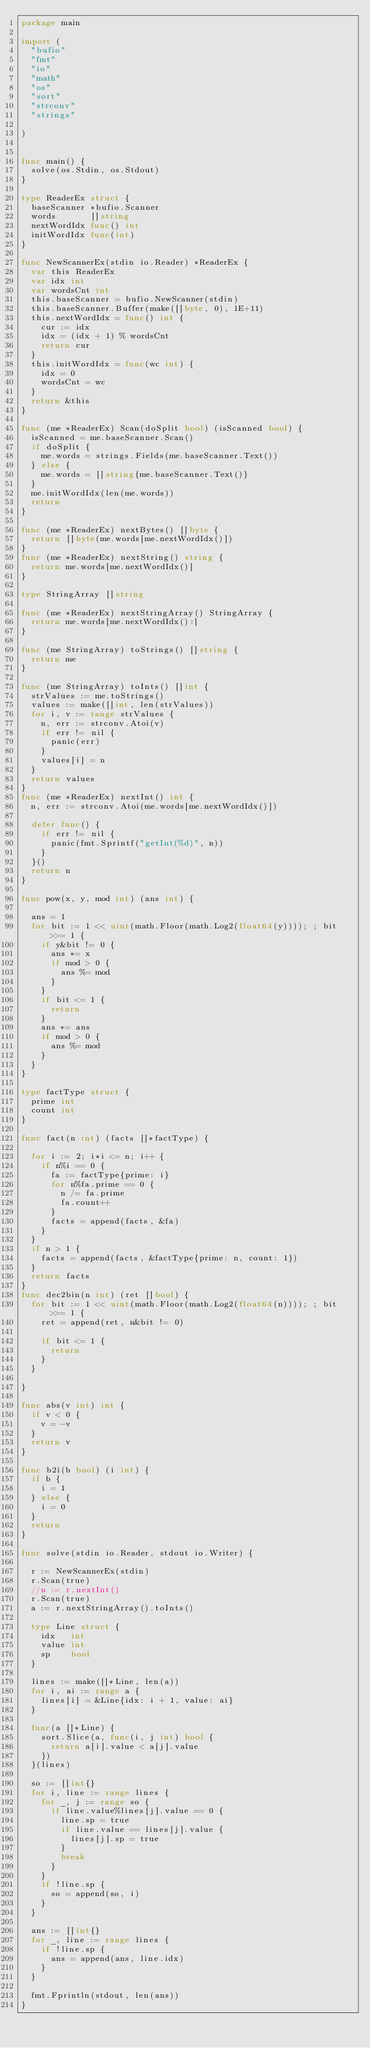<code> <loc_0><loc_0><loc_500><loc_500><_Go_>package main

import (
	"bufio"
	"fmt"
	"io"
	"math"
	"os"
	"sort"
	"strconv"
	"strings"

)


func main() {
	solve(os.Stdin, os.Stdout)
}

type ReaderEx struct {
	baseScanner *bufio.Scanner
	words       []string
	nextWordIdx func() int
	initWordIdx func(int)
}

func NewScannerEx(stdin io.Reader) *ReaderEx {
	var this ReaderEx
	var idx int
	var wordsCnt int
	this.baseScanner = bufio.NewScanner(stdin)
	this.baseScanner.Buffer(make([]byte, 0), 1E+11)
	this.nextWordIdx = func() int {
		cur := idx
		idx = (idx + 1) % wordsCnt
		return cur
	}
	this.initWordIdx = func(wc int) {
		idx = 0
		wordsCnt = wc
	}
	return &this
}

func (me *ReaderEx) Scan(doSplit bool) (isScanned bool) {
	isScanned = me.baseScanner.Scan()
	if doSplit {
		me.words = strings.Fields(me.baseScanner.Text())
	} else {
		me.words = []string{me.baseScanner.Text()}
	}
	me.initWordIdx(len(me.words))
	return
}

func (me *ReaderEx) nextBytes() []byte {
	return []byte(me.words[me.nextWordIdx()])
}
func (me *ReaderEx) nextString() string {
	return me.words[me.nextWordIdx()]
}

type StringArray []string

func (me *ReaderEx) nextStringArray() StringArray {
	return me.words[me.nextWordIdx():]
}

func (me StringArray) toStrings() []string {
	return me
}

func (me StringArray) toInts() []int {
	strValues := me.toStrings()
	values := make([]int, len(strValues))
	for i, v := range strValues {
		n, err := strconv.Atoi(v)
		if err != nil {
			panic(err)
		}
		values[i] = n
	}
	return values
}
func (me *ReaderEx) nextInt() int {
	n, err := strconv.Atoi(me.words[me.nextWordIdx()])

	defer func() {
		if err != nil {
			panic(fmt.Sprintf("getInt(%d)", n))
		}
	}()
	return n
}

func pow(x, y, mod int) (ans int) {

	ans = 1
	for bit := 1 << uint(math.Floor(math.Log2(float64(y)))); ; bit >>= 1 {
		if y&bit != 0 {
			ans *= x
			if mod > 0 {
				ans %= mod
			}
		}
		if bit <= 1 {
			return
		}
		ans *= ans
		if mod > 0 {
			ans %= mod
		}
	}
}

type factType struct {
	prime int
	count int
}

func fact(n int) (facts []*factType) {

	for i := 2; i*i <= n; i++ {
		if n%i == 0 {
			fa := factType{prime: i}
			for n%fa.prime == 0 {
				n /= fa.prime
				fa.count++
			}
			facts = append(facts, &fa)
		}
	}
	if n > 1 {
		facts = append(facts, &factType{prime: n, count: 1})
	}
	return facts
}
func dec2bin(n int) (ret []bool) {
	for bit := 1 << uint(math.Floor(math.Log2(float64(n)))); ; bit >>= 1 {
		ret = append(ret, n&bit != 0)

		if bit <= 1 {
			return
		}
	}

}

func abs(v int) int {
	if v < 0 {
		v = -v
	}
	return v
}

func b2i(b bool) (i int) {
	if b {
		i = 1
	} else {
		i = 0
	}
	return
}

func solve(stdin io.Reader, stdout io.Writer) {

	r := NewScannerEx(stdin)
	r.Scan(true)
	//n := r.nextInt()
	r.Scan(true)
	a := r.nextStringArray().toInts()

	type Line struct {
		idx   int
		value int
		sp    bool
	}

	lines := make([]*Line, len(a))
	for i, ai := range a {
		lines[i] = &Line{idx: i + 1, value: ai}
	}

	func(a []*Line) {
		sort.Slice(a, func(i, j int) bool {
			return a[i].value < a[j].value
		})
	}(lines)

	so := []int{}
	for i, line := range lines {
		for _, j := range so {
			if line.value%lines[j].value == 0 {
				line.sp = true
				if line.value == lines[j].value {
					lines[j].sp = true
				}
				break
			}
		}
		if !line.sp {
			so = append(so, i)
		}
	}

	ans := []int{}
	for _, line := range lines {
		if !line.sp {
			ans = append(ans, line.idx)
		}
	}

	fmt.Fprintln(stdout, len(ans))
}
</code> 